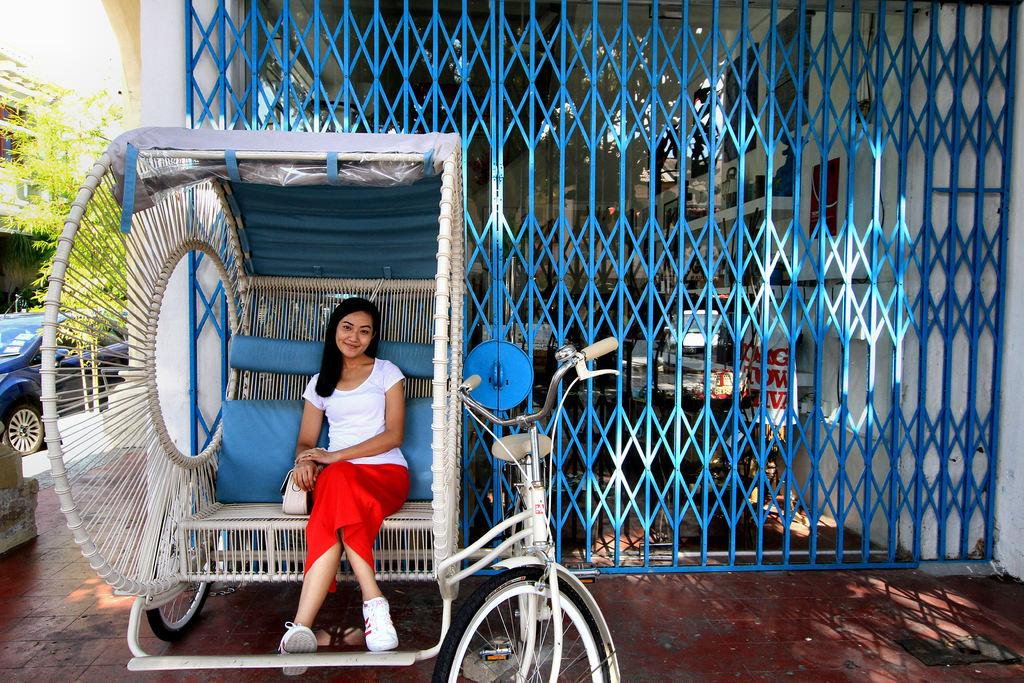What is the lady in the image doing? The lady is sitting on a sofa in the image. What can be seen in the background of the image? There is a gate, trees, and a car in the background of the image. What type of slope is visible in the image? There is no slope visible in the image. 